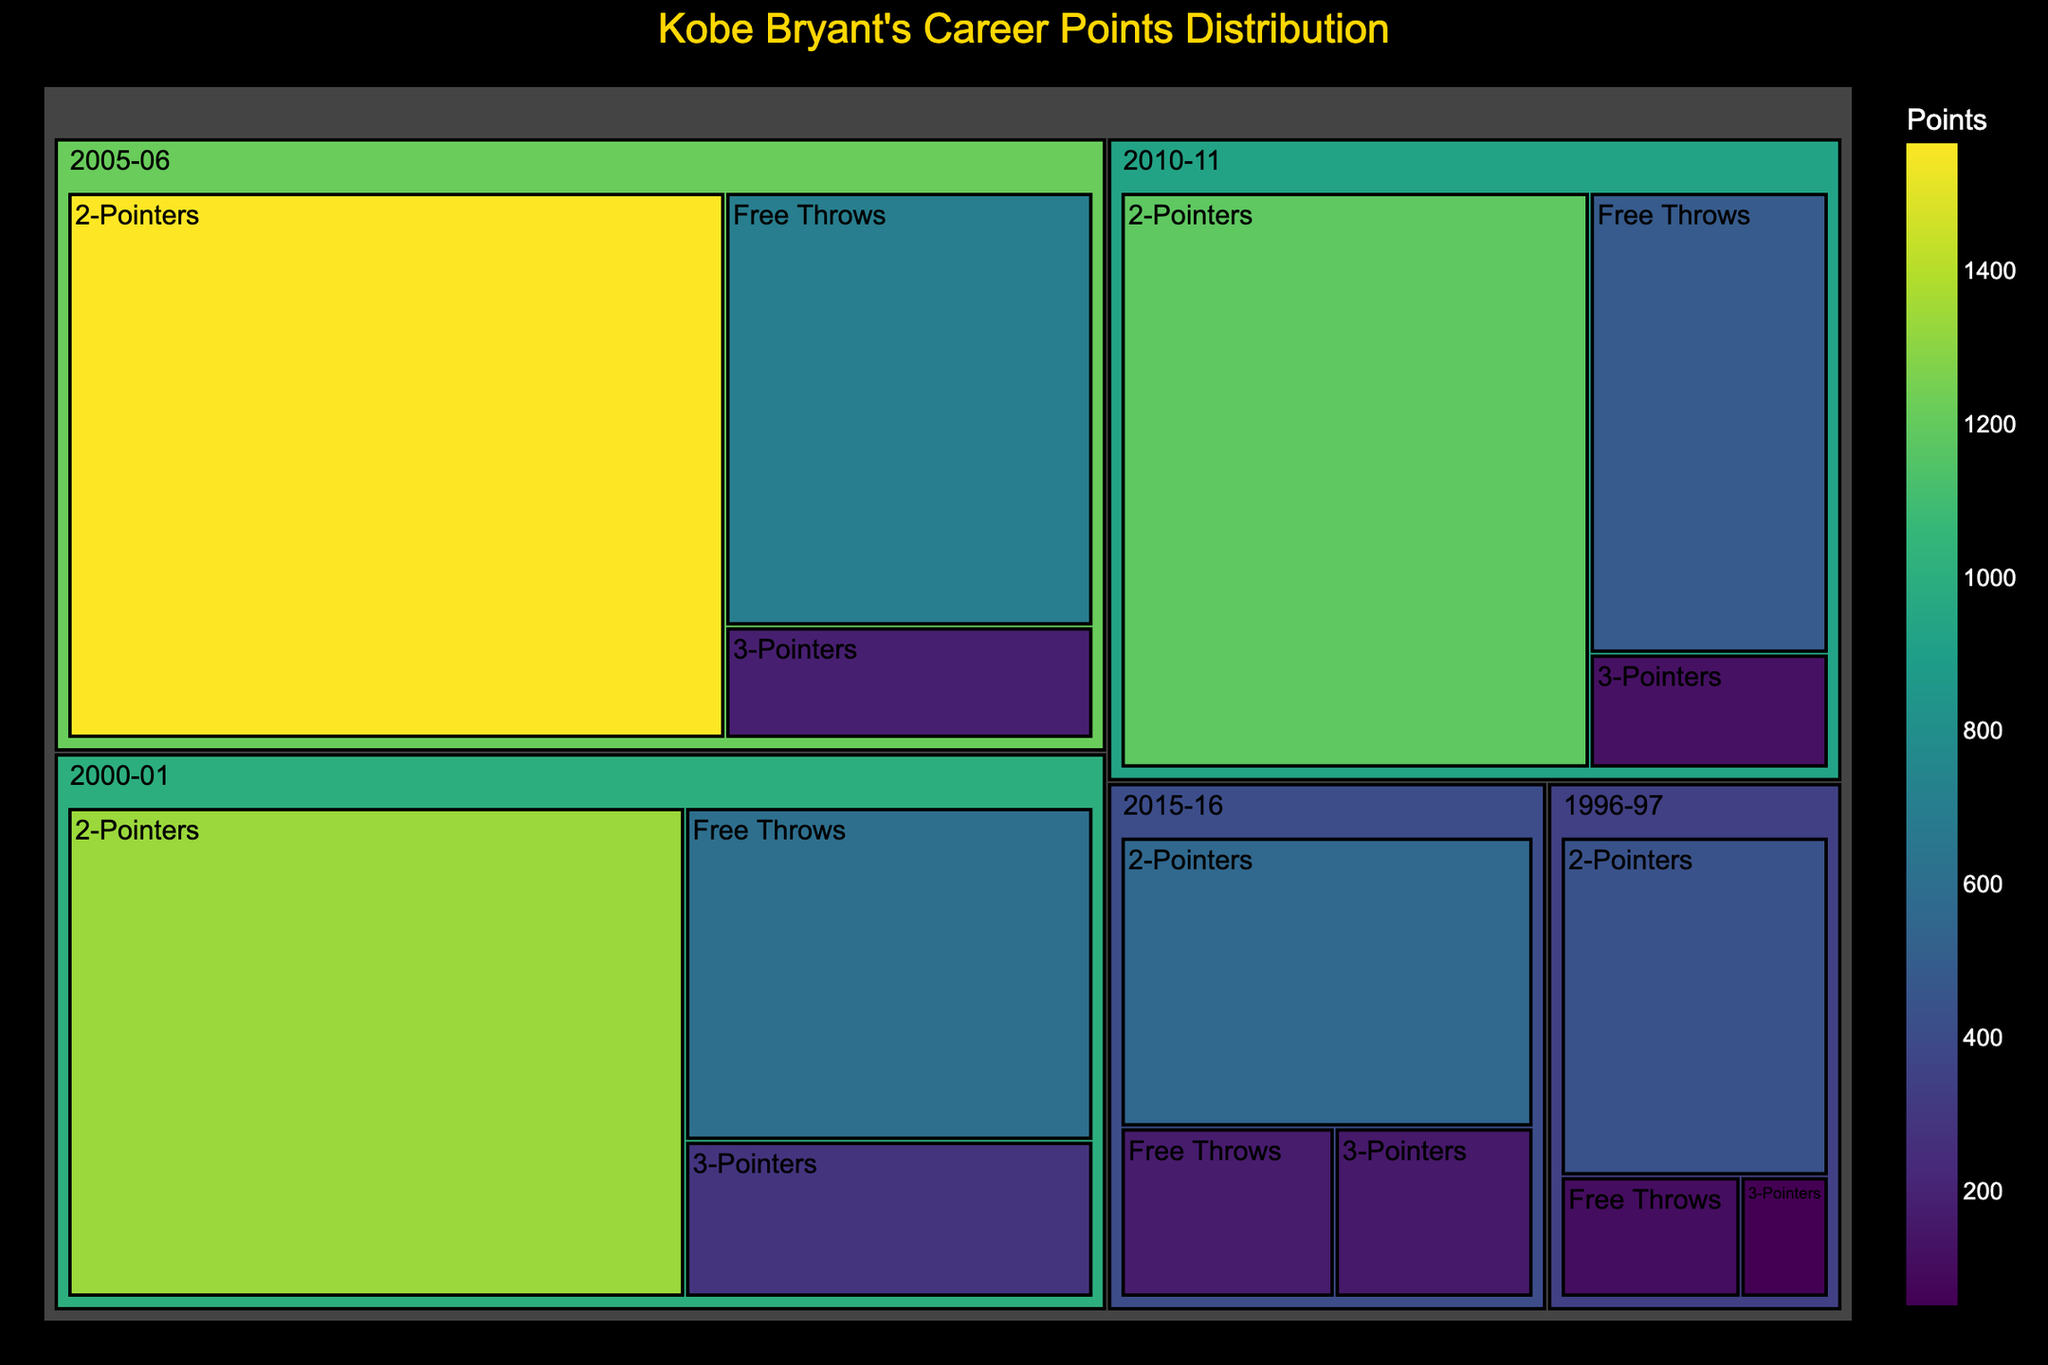What's the overall title of the treemap? The title is shown at the top of the figure and indicates the main subject of the visualization.
Answer: Kobe Bryant's Career Points Distribution How many seasons are represented in the treemap? Count the distinct sections labeled with different years corresponding to each season.
Answer: 5 Which season shows the highest contribution of 3-Pointers? Compare the size and points of the sections related to 3-Pointers across all seasons represented in the treemap.
Answer: 2000-01 What is the total number of points Kobe Bryant scored from 2-Pointers in 2005-06? Locate the section representing the 2005-06 season, find the 2-Pointers subsection, and read the points.
Answer: 1566 In terms of Free Throws, which season had the least contribution? Identify the Free Throws sections for each season and compare their sizes/points to determine the smallest.
Answer: 1996-97 Compare the total points from 3-Pointers between 1996-97 and 2015-16. Which is higher? Look at the points listed for 3-Pointers in both seasons and compare the two values.
Answer: 2015-16 How many more points were scored from 2-Pointers in 2010-11 than from 2-Pointers in 1996-97? Subtract the 2-Pointer points in 1996-97 from those in 2010-11 (1184 - 434).
Answer: 750 Which season shows the highest total points contribution across all shot types? Sum the points for 2-Pointers, 3-Pointers, and Free Throws for each season, and identify the season with the highest total.
Answer: 2005-06 Determine the average points scored from Free Throws across the 5 seasons. Sum all Free Throws points across the seasons and divide by the total number of seasons (104 + 601 + 696 + 483 + 168) / 5.
Answer: 410.4 Which season had the lowest number of points from 3-Pointers, and how many points were scored? Compare the size and points of the 3-Pointers sections for each season, and identify the lowest.
Answer: 1996-97, 51 